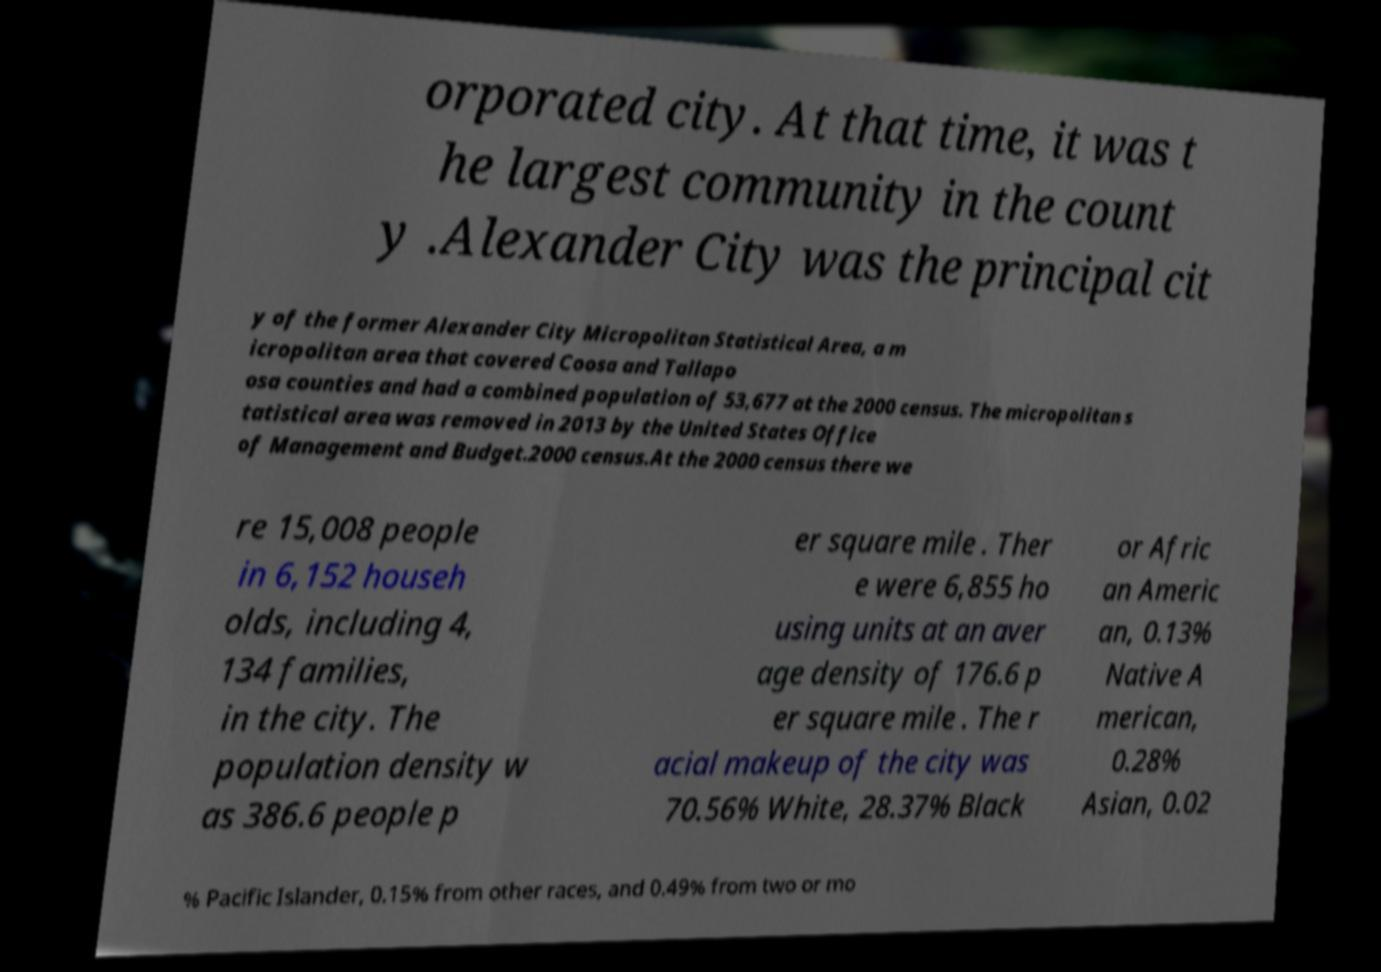There's text embedded in this image that I need extracted. Can you transcribe it verbatim? orporated city. At that time, it was t he largest community in the count y .Alexander City was the principal cit y of the former Alexander City Micropolitan Statistical Area, a m icropolitan area that covered Coosa and Tallapo osa counties and had a combined population of 53,677 at the 2000 census. The micropolitan s tatistical area was removed in 2013 by the United States Office of Management and Budget.2000 census.At the 2000 census there we re 15,008 people in 6,152 househ olds, including 4, 134 families, in the city. The population density w as 386.6 people p er square mile . Ther e were 6,855 ho using units at an aver age density of 176.6 p er square mile . The r acial makeup of the city was 70.56% White, 28.37% Black or Afric an Americ an, 0.13% Native A merican, 0.28% Asian, 0.02 % Pacific Islander, 0.15% from other races, and 0.49% from two or mo 